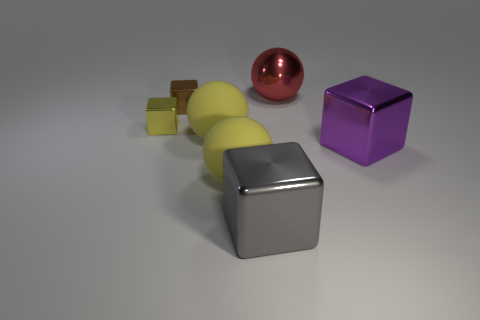How many red rubber cylinders are there?
Make the answer very short. 0. Do the brown block and the red sphere have the same size?
Offer a terse response. No. How many other objects are there of the same shape as the yellow metallic object?
Offer a very short reply. 3. What is the material of the object left of the block that is behind the yellow cube?
Offer a very short reply. Metal. There is a red ball; are there any gray metallic blocks on the left side of it?
Make the answer very short. Yes. There is a brown metal cube; is it the same size as the metal object on the left side of the small brown object?
Provide a short and direct response. Yes. The brown object that is the same shape as the large purple thing is what size?
Offer a terse response. Small. Is the size of the brown object behind the yellow shiny object the same as the object on the right side of the large red object?
Give a very brief answer. No. How many large things are red cubes or gray shiny things?
Offer a terse response. 1. What number of large objects are both in front of the red shiny object and right of the big gray shiny block?
Offer a very short reply. 1. 